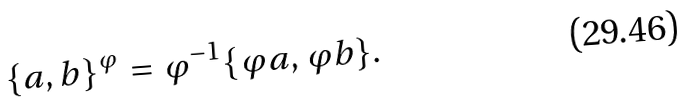Convert formula to latex. <formula><loc_0><loc_0><loc_500><loc_500>\{ a , b \} ^ { \varphi } = \varphi ^ { - 1 } \{ \varphi a , \varphi b \} .</formula> 